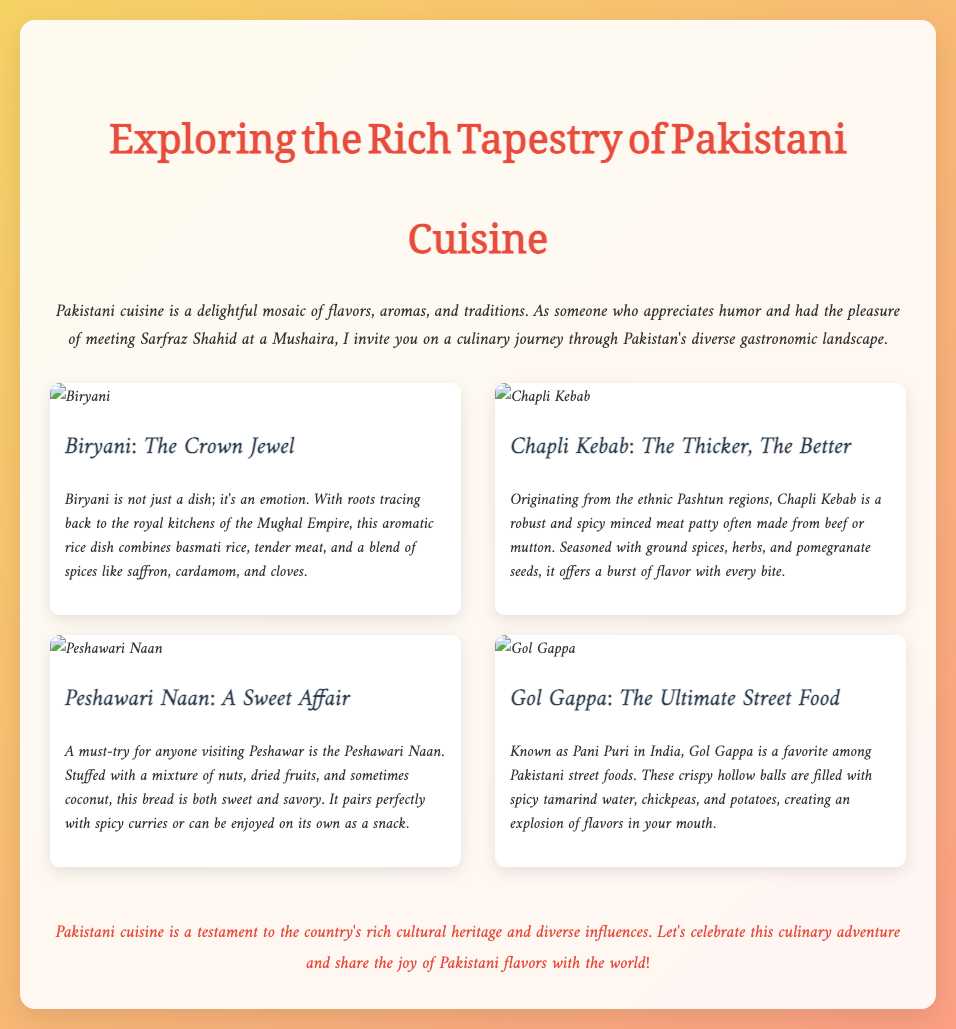What is the title of the presentation? The title of the presentation is prominently displayed at the top of the slide.
Answer: Exploring the Rich Tapestry of Pakistani Cuisine What dish is referred to as “The Crown Jewel”? The slide specifically names one dish with this title.
Answer: Biryani From which regions does Chapli Kebab originate? The document mentions the ethnic origins of Chapli Kebab.
Answer: Pashtun What key ingredient is highlighted in Gol Gappa? The description focuses on a specific key element that defines this street food.
Answer: Tamarind water Which type of bread is described as "A Sweet Affair"? The document categorizes one of the dishes with this phrase.
Answer: Peshawari Naan What is the emotion associated with Biryani? The content explicitly states the sentiment related to this dish.
Answer: Emotion What is the purpose of the concluding statement? The conclusion summarizes the overall theme of the presentation regarding cuisine.
Answer: To celebrate Pakistani cuisine How many dishes are featured in the presentation? By counting the number of unique dishes mentioned, this question can be answered.
Answer: Four What two flavors does Peshawari Naan feature? The description highlights the contrasting aspects of this bread.
Answer: Sweet and savory 